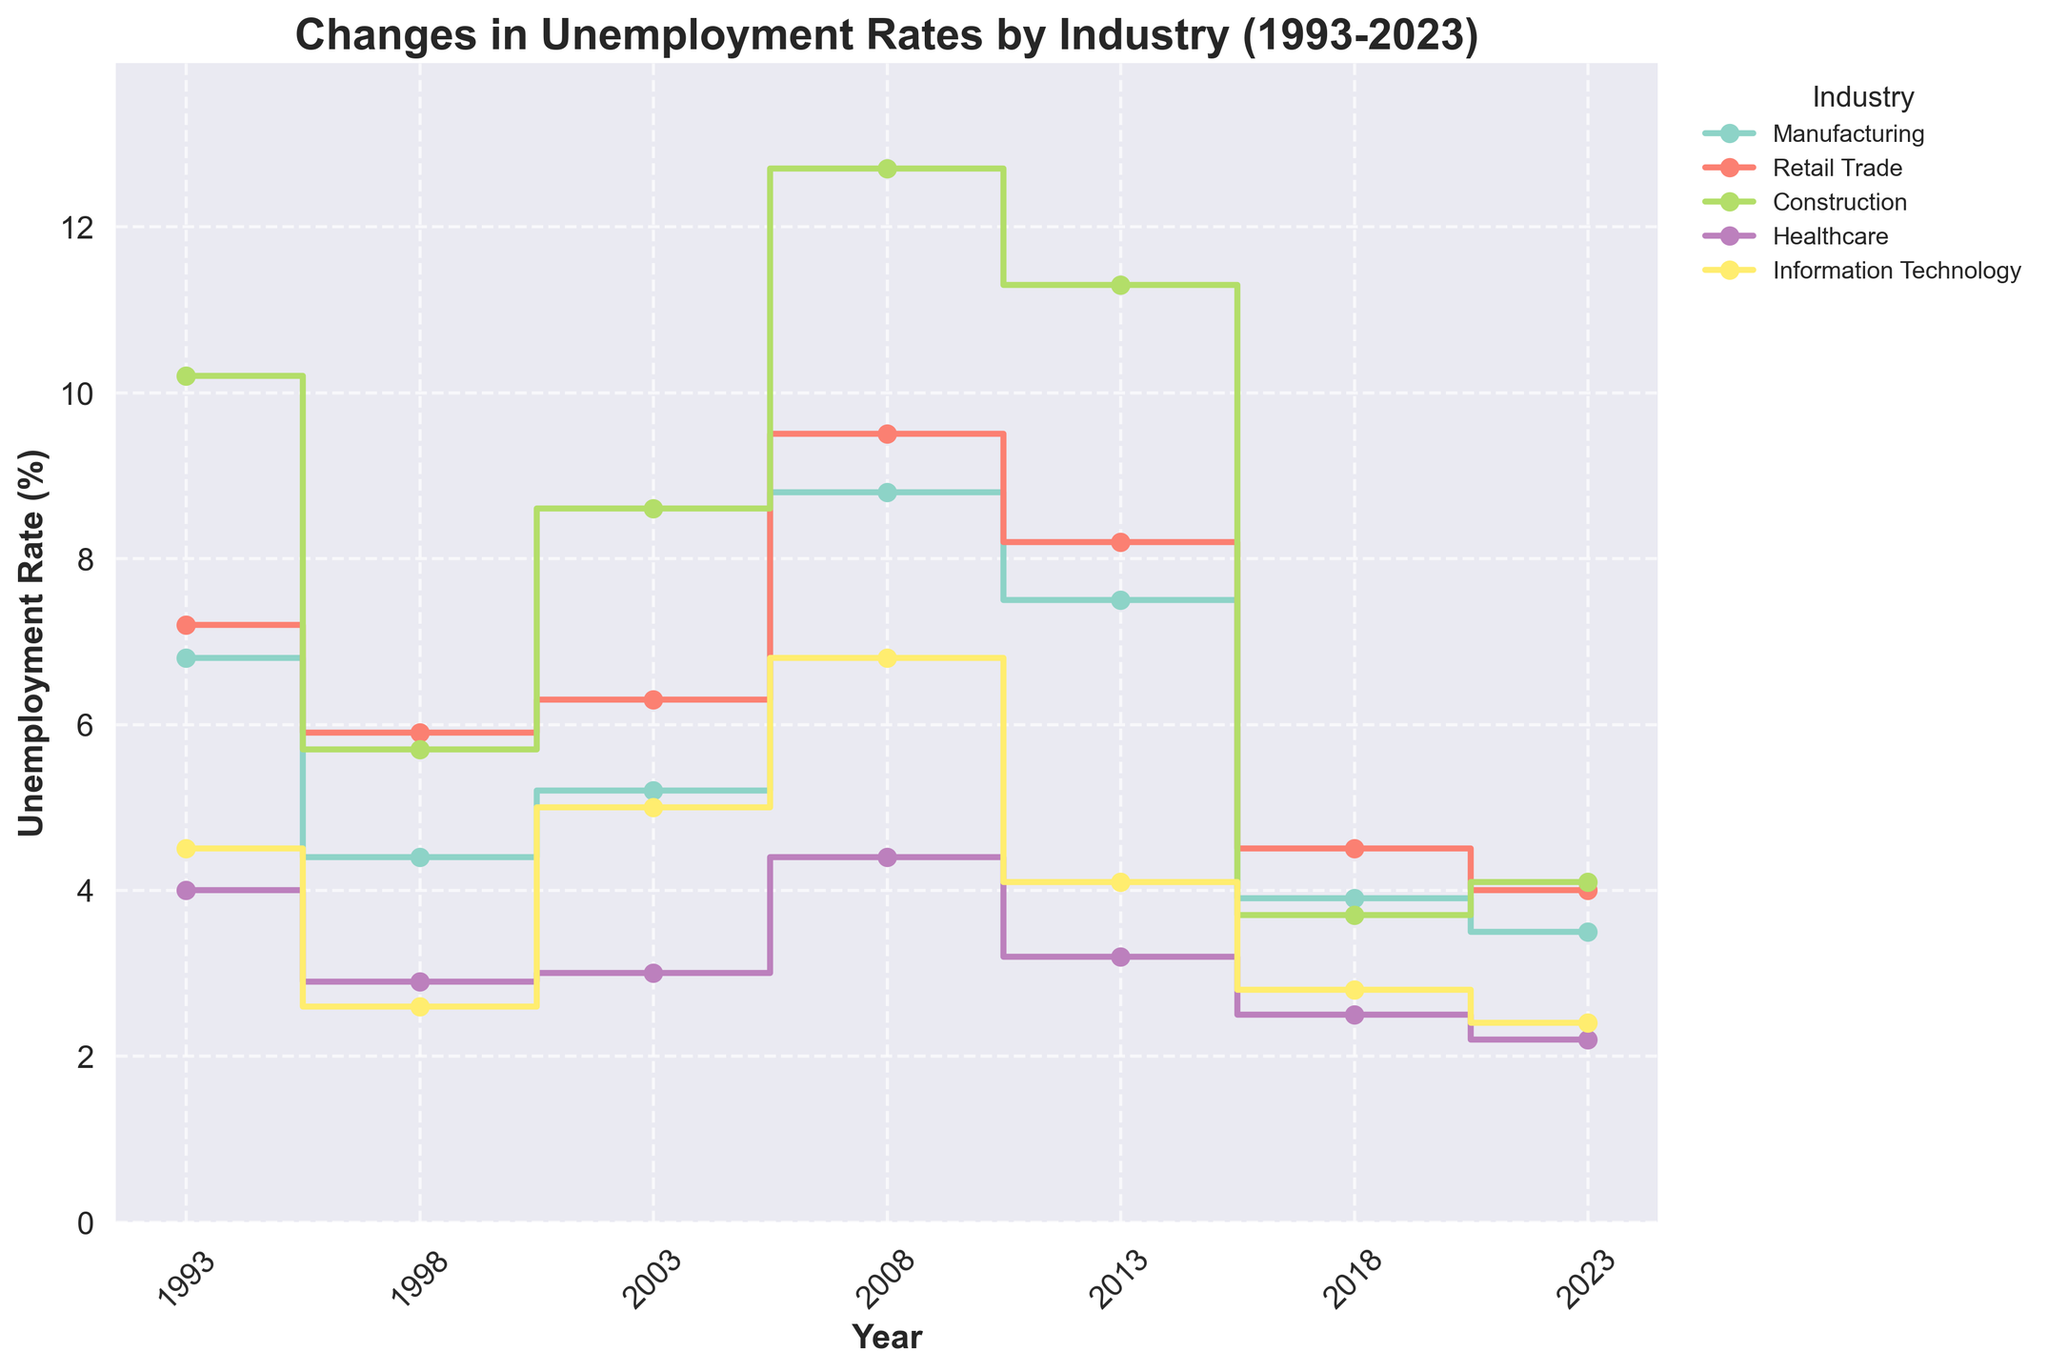What is the title of the plot? The title of the plot is clearly written at the top of the figure and specifies the subject of the data being visualized.
Answer: Changes in Unemployment Rates by Industry (1993-2023) How many industries are shown in the plot? Count the number of lines in the legend, each representing a different industry.
Answer: 5 Which year had the highest unemployment rate in the Construction industry? Identify the peak point in the stair-step line corresponding to the Construction industry and read the year value.
Answer: 2008 What is the unemployment rate for Healthcare in 2023? Look for the point in the stair-step line for Healthcare at the 2023 mark and read the unemployment rate.
Answer: 2.2% Which industry experienced the most significant drop in unemployment rate from 2008 to 2018? For each industry, calculate the difference in unemployment rates between 2008 and 2018, and identify the industry with the largest decrease.
Answer: Construction What is the average unemployment rate for Manufacturing over the years depicted? Sum the unemployment rates for Manufacturing for all the years and divide by the number of data points (7 years).
Answer: (6.8 + 4.4 + 5.2 + 8.8 + 7.5 + 3.9 + 3.5)/7 = 5.87% Which two industries had nearly the same unemployment rate in 2023? Compare the unemployment rates for all industries in 2023 and identify the two that have almost equal values.
Answer: Retail Trade (4.0%) and Construction (4.1%) Between which consecutive years did Retail Trade see the largest increase in unemployment rate? Calculate the difference in unemployment rates for each consecutive year pair in the Retail Trade series and identify the pair with the largest positive difference.
Answer: 2003 to 2008 Which industry shows the lowest overall trend in unemployment rates over the 30 years? Compare the trends in the stair-step lines over the entire period for all industries and identify the one with the consistently lowest rates.
Answer: Healthcare 